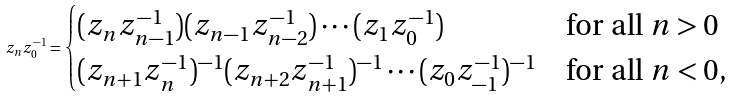Convert formula to latex. <formula><loc_0><loc_0><loc_500><loc_500>z _ { n } z _ { 0 } ^ { - 1 } = \begin{cases} ( z _ { n } z _ { n - 1 } ^ { - 1 } ) ( z _ { n - 1 } z _ { n - 2 } ^ { - 1 } ) \cdots ( z _ { 1 } z _ { 0 } ^ { - 1 } ) & \text {for all $n>0$} \\ ( z _ { n + 1 } z _ { n } ^ { - 1 } ) ^ { - 1 } ( z _ { n + 2 } z _ { n + 1 } ^ { - 1 } ) ^ { - 1 } \cdots ( z _ { 0 } z _ { - 1 } ^ { - 1 } ) ^ { - 1 } & \text {for all $n<0$,} \end{cases}</formula> 